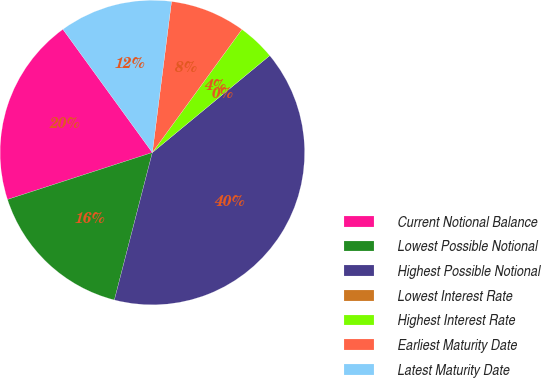<chart> <loc_0><loc_0><loc_500><loc_500><pie_chart><fcel>Current Notional Balance<fcel>Lowest Possible Notional<fcel>Highest Possible Notional<fcel>Lowest Interest Rate<fcel>Highest Interest Rate<fcel>Earliest Maturity Date<fcel>Latest Maturity Date<nl><fcel>20.0%<fcel>16.0%<fcel>40.0%<fcel>0.0%<fcel>4.0%<fcel>8.0%<fcel>12.0%<nl></chart> 